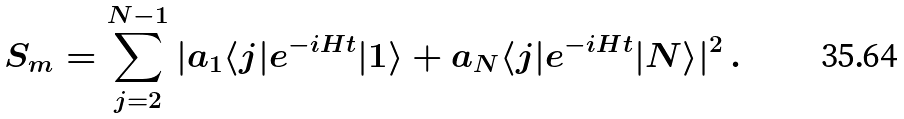<formula> <loc_0><loc_0><loc_500><loc_500>S _ { m } = \sum _ { j = 2 } ^ { N - 1 } | a _ { 1 } \langle j | e ^ { - i H t } | 1 \rangle + a _ { N } \langle j | e ^ { - i H t } | N \rangle | ^ { 2 } \, .</formula> 